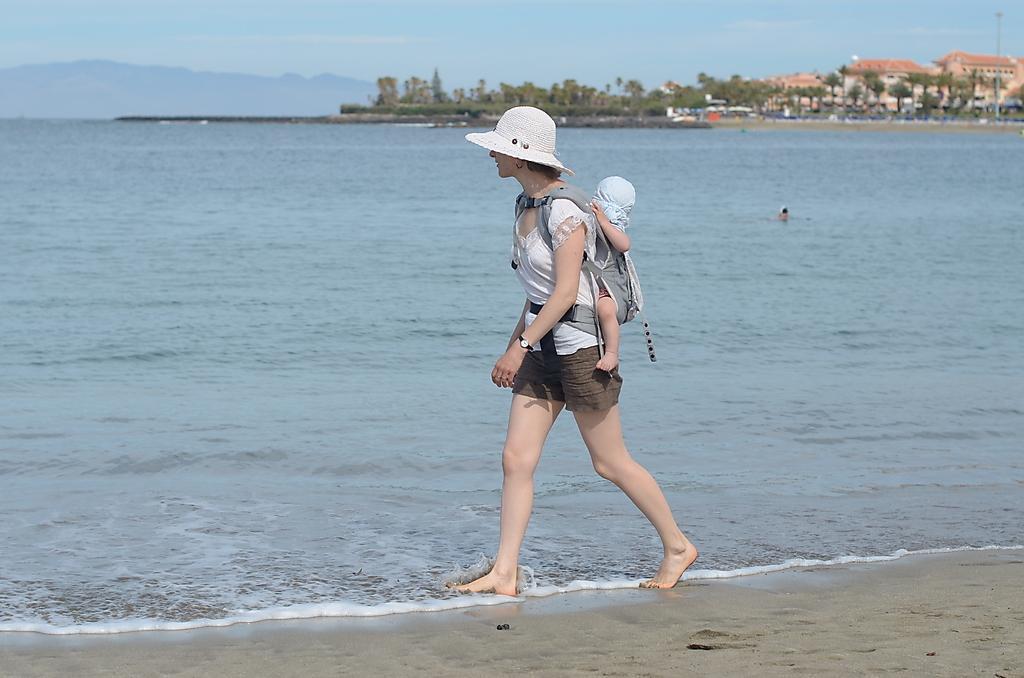Could you give a brief overview of what you see in this image? In this image I can see the person walking and the person is wearing white and brown color dress and I can see the baby back of the person. Background I can see the water, trees in green color, few buildings and the sky is in blue color. 